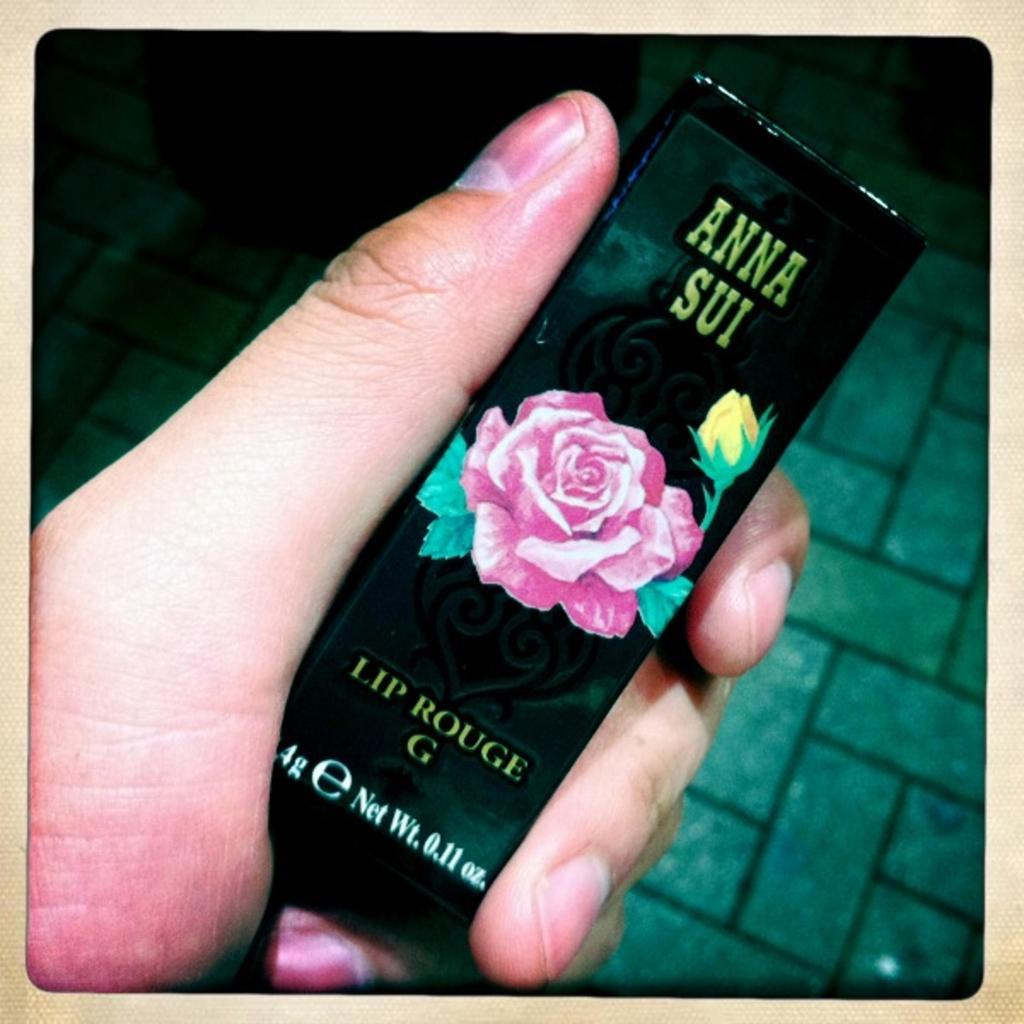What is being held in the image? There is an object being held in the image. Whose hand is holding the object? The object is being held by a hand. What can be seen in the background of the image? There is a floor visible in the background of the image. What type of goldfish is swimming in the background of the image? There are no goldfish present in the image; it only features an object being held by a hand with a floor visible in the background. 